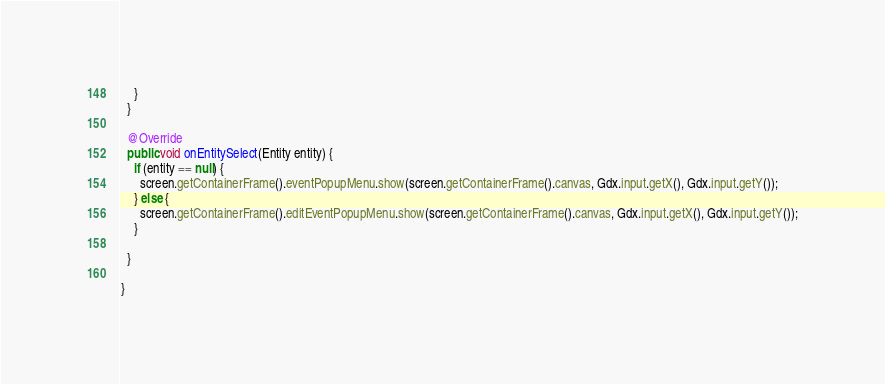Convert code to text. <code><loc_0><loc_0><loc_500><loc_500><_Java_>    }
  }

  @Override
  public void onEntitySelect(Entity entity) {
    if (entity == null) {
      screen.getContainerFrame().eventPopupMenu.show(screen.getContainerFrame().canvas, Gdx.input.getX(), Gdx.input.getY());
    } else {
      screen.getContainerFrame().editEventPopupMenu.show(screen.getContainerFrame().canvas, Gdx.input.getX(), Gdx.input.getY());
    }
    
  }

}
</code> 